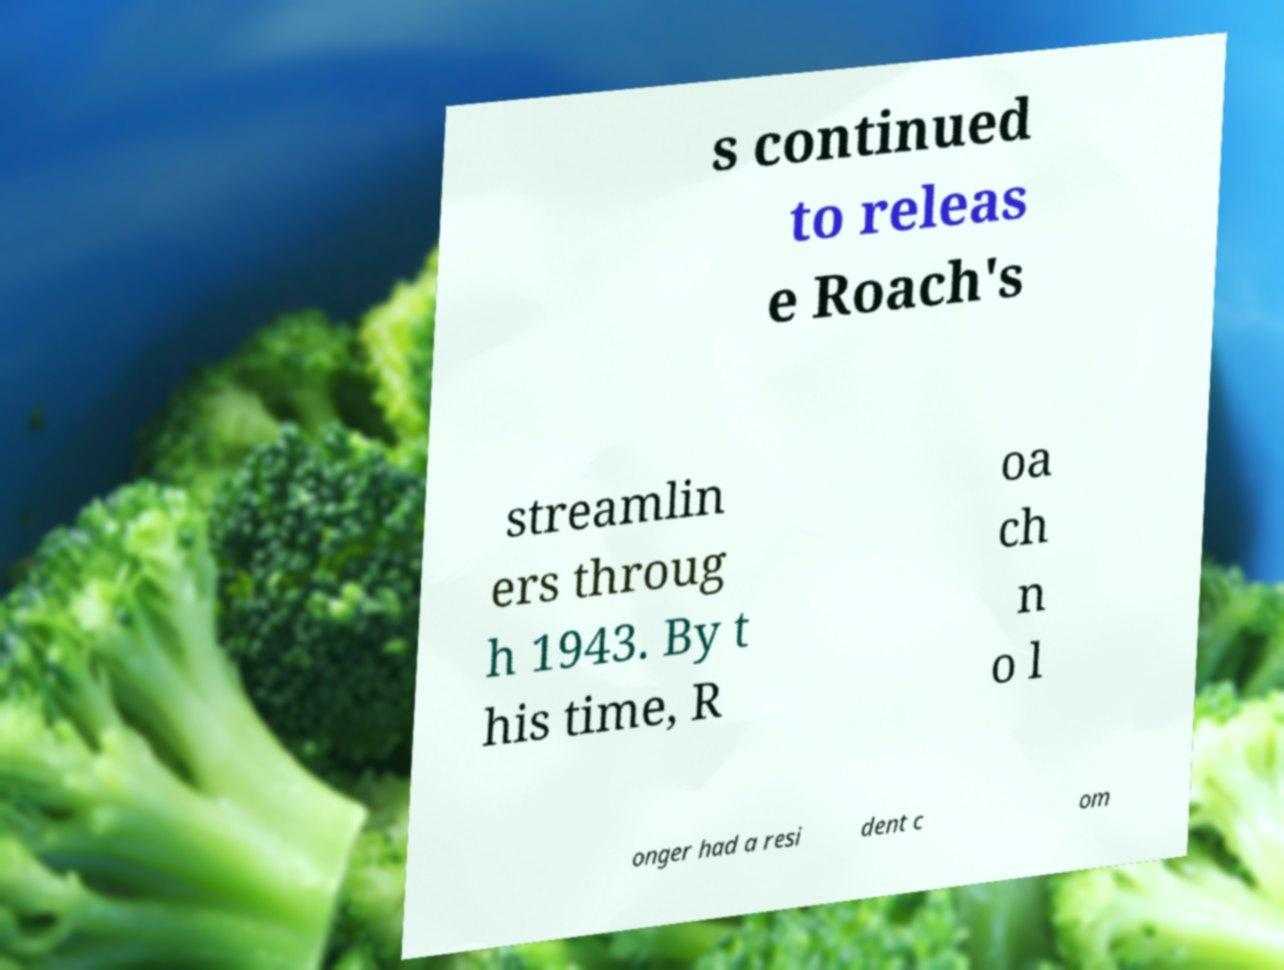Please identify and transcribe the text found in this image. s continued to releas e Roach's streamlin ers throug h 1943. By t his time, R oa ch n o l onger had a resi dent c om 